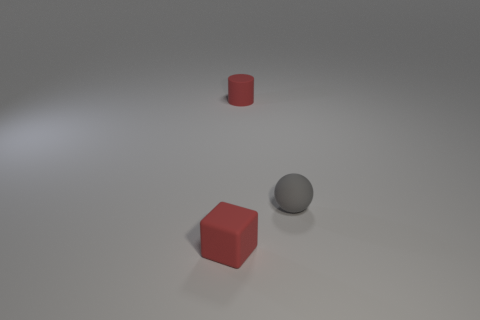Are any blue shiny balls visible?
Keep it short and to the point. No. Are there any large cyan blocks made of the same material as the red block?
Keep it short and to the point. No. Are there more matte spheres that are to the right of the small red rubber cylinder than matte spheres that are behind the tiny gray ball?
Offer a terse response. Yes. Is the size of the red cube the same as the cylinder?
Make the answer very short. Yes. There is a small rubber thing that is to the left of the red thing behind the small red rubber cube; what is its color?
Offer a terse response. Red. What color is the cylinder?
Make the answer very short. Red. Are there any matte cylinders that have the same color as the matte sphere?
Keep it short and to the point. No. There is a thing that is in front of the gray matte ball; is its color the same as the tiny matte cylinder?
Provide a short and direct response. Yes. How many things are small things that are on the left side of the gray ball or large purple rubber blocks?
Ensure brevity in your answer.  2. Are there any matte objects to the left of the gray ball?
Offer a terse response. Yes. 